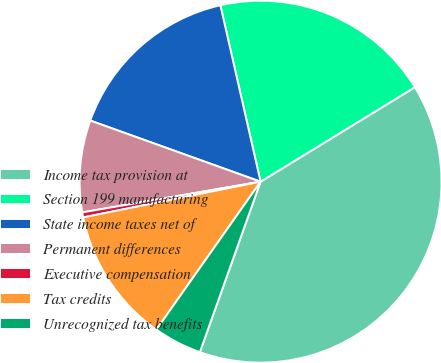Convert chart to OTSL. <chart><loc_0><loc_0><loc_500><loc_500><pie_chart><fcel>Income tax provision at<fcel>Section 199 manufacturing<fcel>State income taxes net of<fcel>Permanent differences<fcel>Executive compensation<fcel>Tax credits<fcel>Unrecognized tax benefits<nl><fcel>39.19%<fcel>19.82%<fcel>15.95%<fcel>8.2%<fcel>0.45%<fcel>12.07%<fcel>4.32%<nl></chart> 